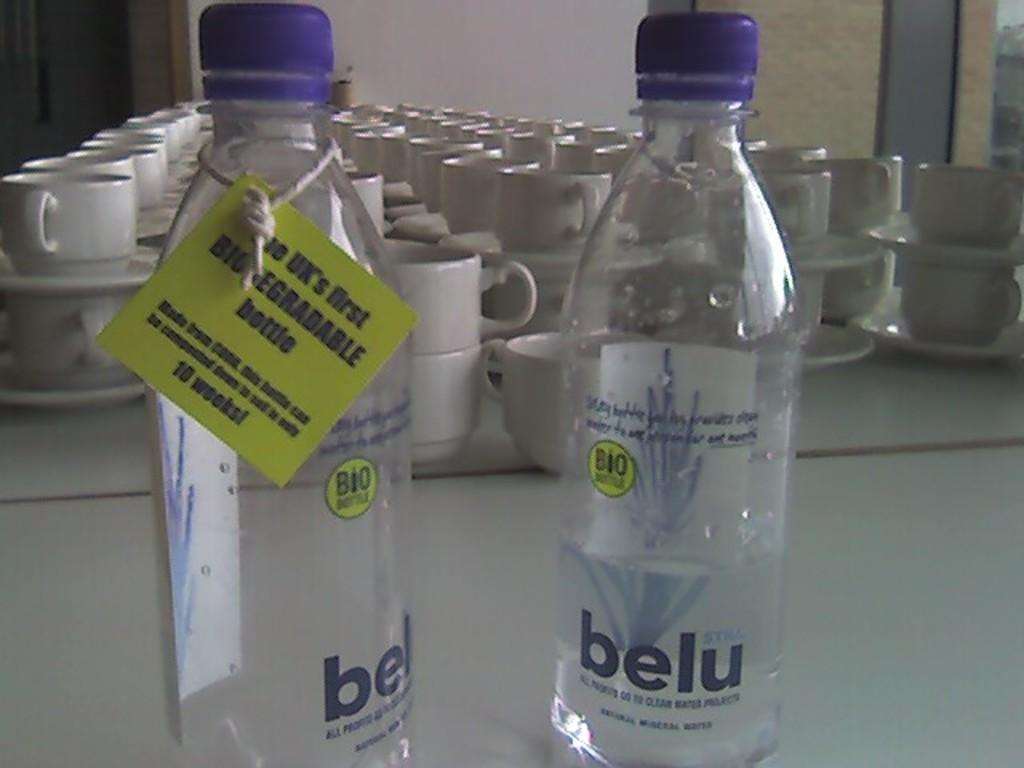Provide a one-sentence caption for the provided image. Two bottles of belu sit on a table in front of cups and saucers. 